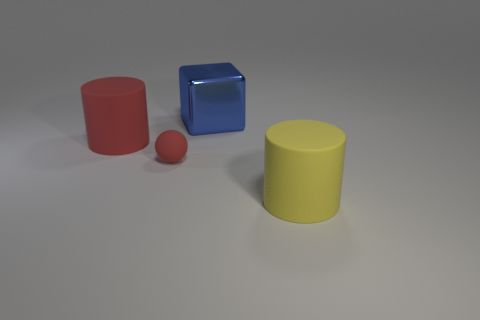Is there anything else that has the same shape as the big blue object?
Give a very brief answer. No. Is the number of small cyan metal blocks greater than the number of rubber objects?
Give a very brief answer. No. What number of other things are made of the same material as the tiny red ball?
Provide a succinct answer. 2. What number of things are tiny red matte spheres or large cylinders to the right of the matte sphere?
Provide a short and direct response. 2. Is the number of metallic things less than the number of brown matte things?
Ensure brevity in your answer.  No. There is a large cylinder that is behind the red rubber thing that is in front of the cylinder that is to the left of the big shiny cube; what is its color?
Offer a very short reply. Red. Do the tiny ball and the big yellow cylinder have the same material?
Provide a succinct answer. Yes. What number of red spheres are on the right side of the large red matte cylinder?
Provide a succinct answer. 1. How many blue objects are tiny matte cylinders or large metallic cubes?
Ensure brevity in your answer.  1. How many red rubber cylinders are behind the cylinder that is left of the large yellow thing?
Your answer should be very brief. 0. 